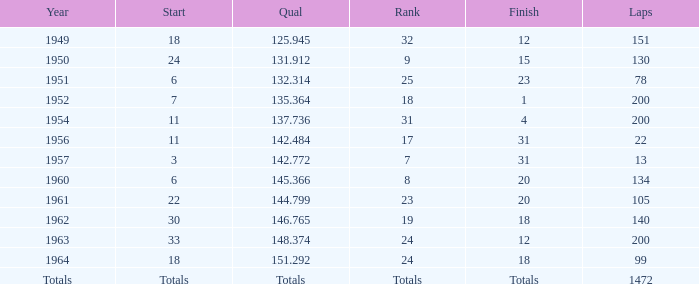What year had 200 laps and a 24th ranking? 1963.0. 